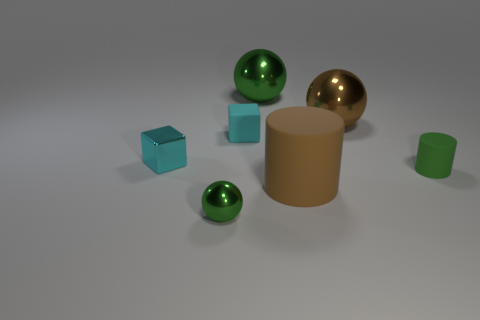Add 2 tiny green metallic objects. How many objects exist? 9 Subtract all blocks. How many objects are left? 5 Subtract all tiny spheres. Subtract all cylinders. How many objects are left? 4 Add 1 large matte cylinders. How many large matte cylinders are left? 2 Add 6 yellow matte cubes. How many yellow matte cubes exist? 6 Subtract 0 red spheres. How many objects are left? 7 